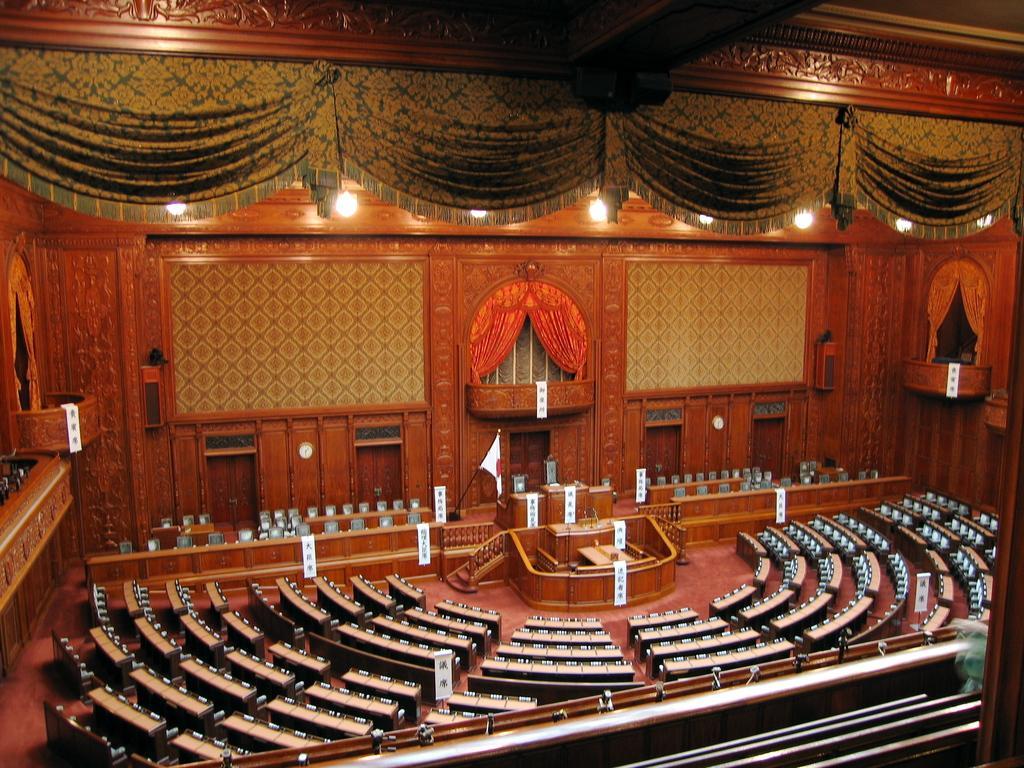How would you summarize this image in a sentence or two? In this picture we can see the inside view of the legislature assembly hall. In the front there are some wooden benches. Behind we can see the podium stage and Japanese flag. In the background we can see a wooden panel wall and an orange curtain.  